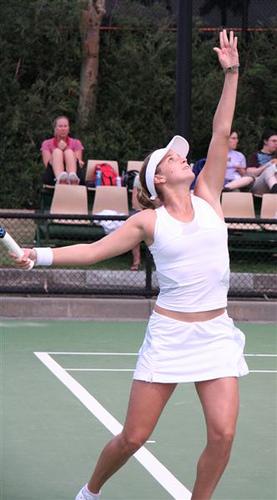Which hand is raised?
Answer briefly. Left. What sport is being played?
Short answer required. Tennis. Which wrist has a sweatband?
Write a very short answer. Right. 